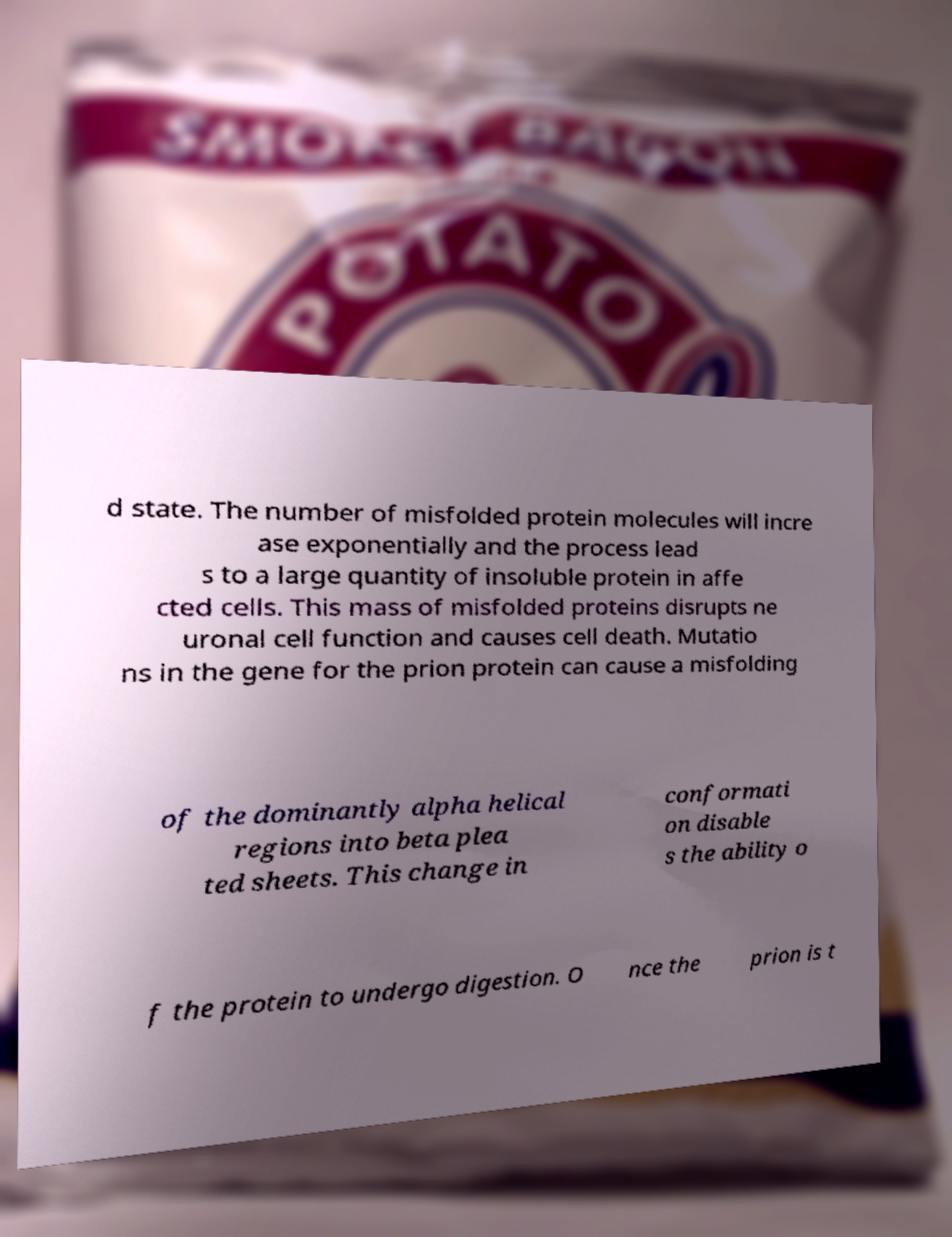Please read and relay the text visible in this image. What does it say? d state. The number of misfolded protein molecules will incre ase exponentially and the process lead s to a large quantity of insoluble protein in affe cted cells. This mass of misfolded proteins disrupts ne uronal cell function and causes cell death. Mutatio ns in the gene for the prion protein can cause a misfolding of the dominantly alpha helical regions into beta plea ted sheets. This change in conformati on disable s the ability o f the protein to undergo digestion. O nce the prion is t 